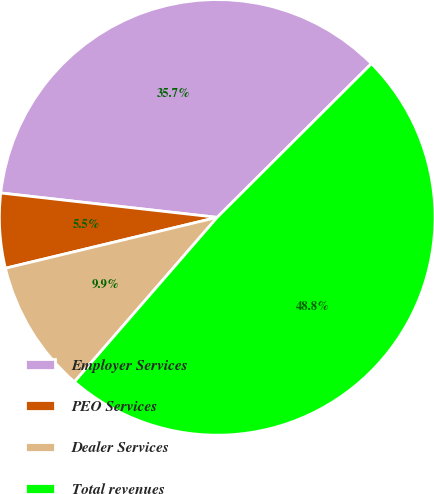<chart> <loc_0><loc_0><loc_500><loc_500><pie_chart><fcel>Employer Services<fcel>PEO Services<fcel>Dealer Services<fcel>Total revenues<nl><fcel>35.74%<fcel>5.54%<fcel>9.87%<fcel>48.85%<nl></chart> 